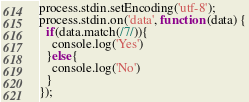<code> <loc_0><loc_0><loc_500><loc_500><_JavaScript_>process.stdin.setEncoding('utf-8');
process.stdin.on('data', function (data) {
  if(data.match(/7/)){
    console.log('Yes')
  }else{
    console.log('No')
  }
});</code> 